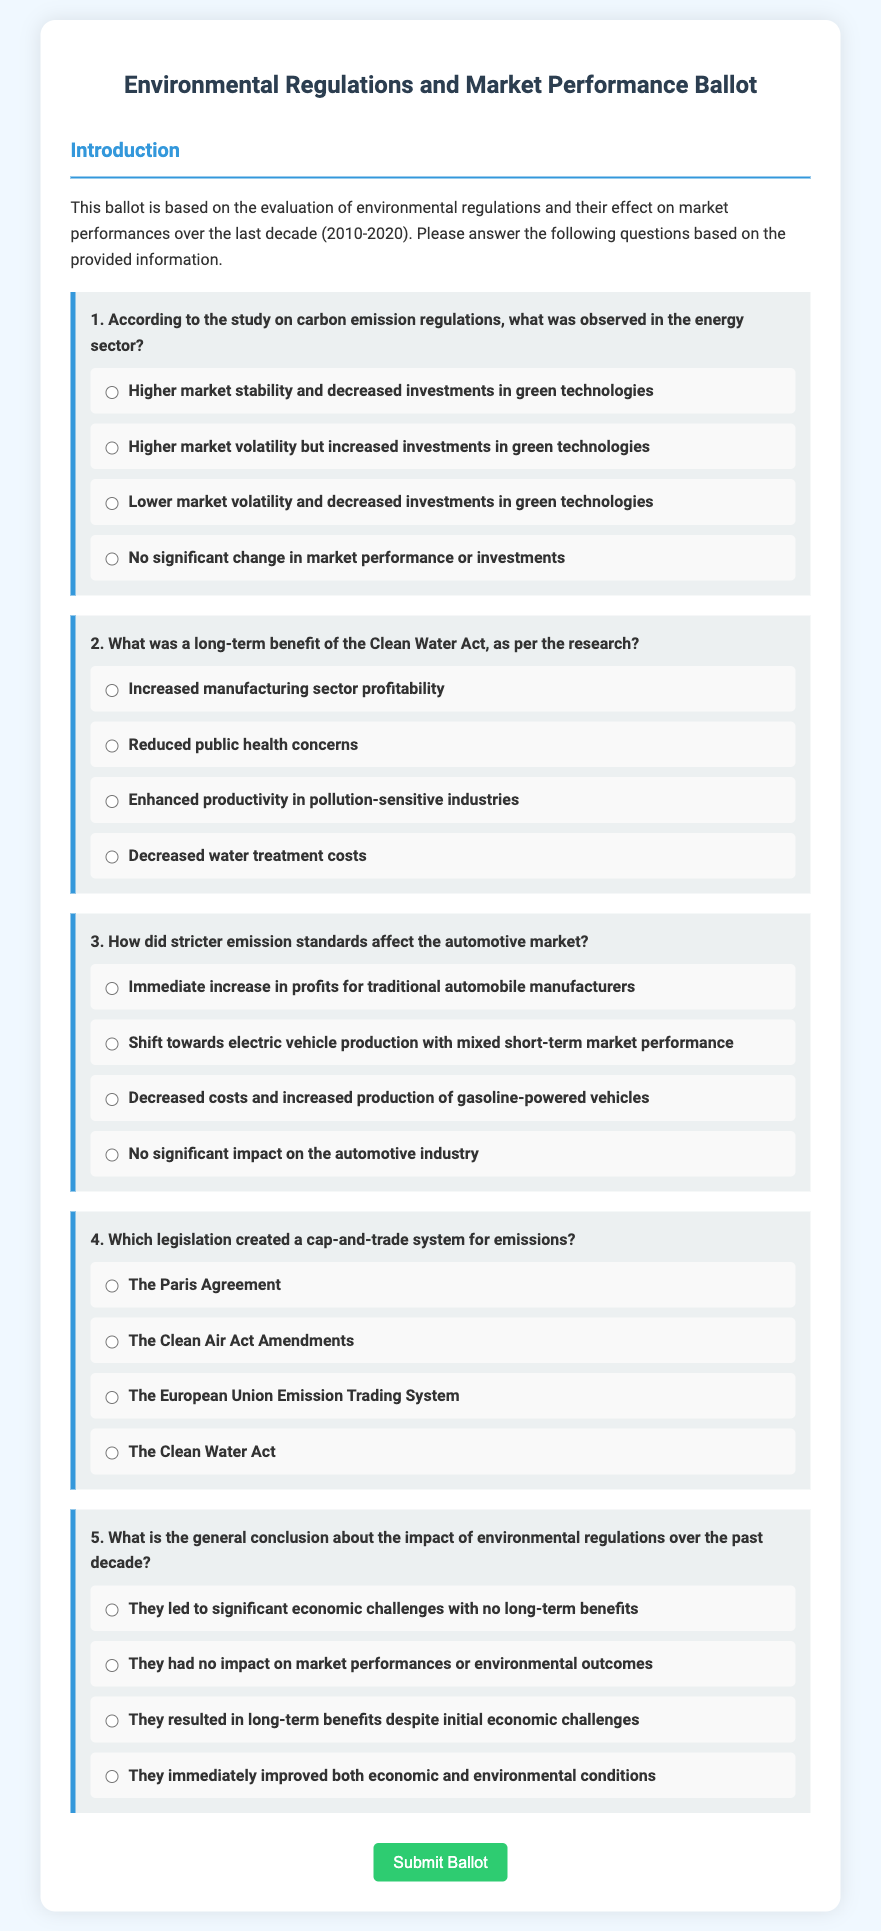What is the title of the ballot? The title of the ballot is specified at the top of the document and is "Environmental Regulations and Market Performance Ballot."
Answer: Environmental Regulations and Market Performance Ballot What time period does the evaluation cover? The evaluation period is mentioned in the introduction, which states it covers the last decade from 2010 to 2020.
Answer: 2010-2020 Which sector showed higher market volatility according to the study? The answer can be found in the first question regarding carbon emission regulations, which states higher market volatility was observed in the energy sector.
Answer: Energy sector What long-term benefit is associated with the Clean Water Act? The second question indicates one of the long-term benefits of the Clean Water Act is reduced public health concerns.
Answer: Reduced public health concerns Which legislation is mentioned as creating a cap-and-trade system for emissions? The fourth question presents options, stating that the European Union Emission Trading System created a cap-and-trade system.
Answer: European Union Emission Trading System What general conclusion is drawn about environmental regulations over the past decade? The fifth question asks for the overall conclusion, which indicates they resulted in long-term benefits despite initial economic challenges.
Answer: Long-term benefits despite initial economic challenges 